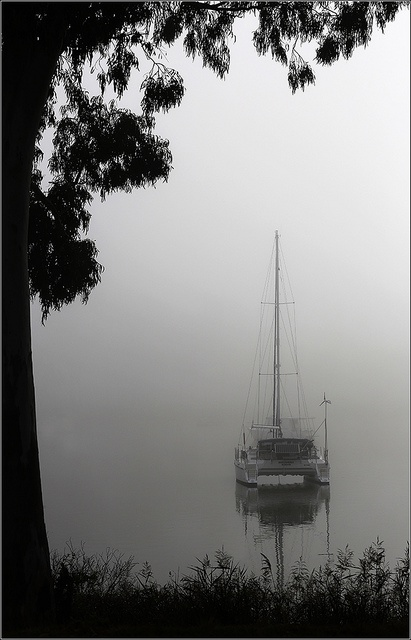Describe the objects in this image and their specific colors. I can see a boat in black, darkgray, gray, and lightgray tones in this image. 